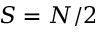Convert formula to latex. <formula><loc_0><loc_0><loc_500><loc_500>S = N / 2</formula> 